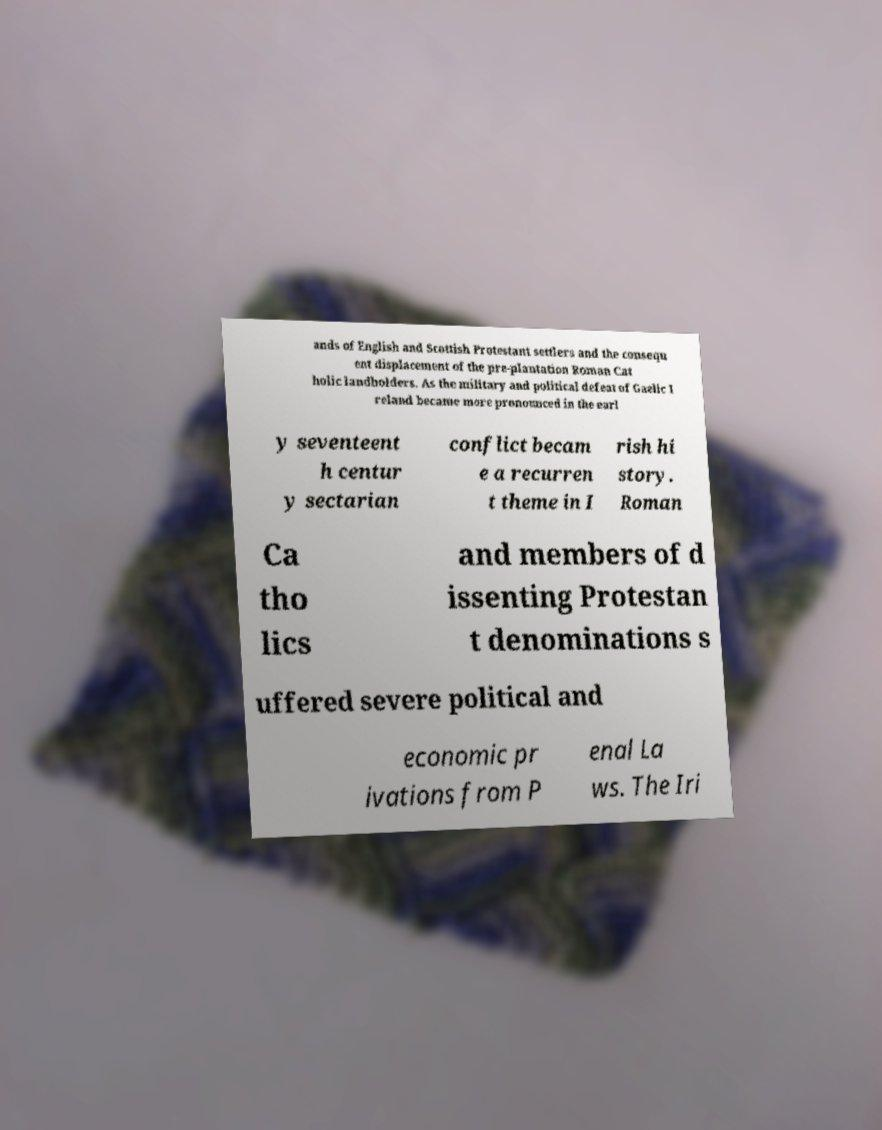There's text embedded in this image that I need extracted. Can you transcribe it verbatim? ands of English and Scottish Protestant settlers and the consequ ent displacement of the pre-plantation Roman Cat holic landholders. As the military and political defeat of Gaelic I reland became more pronounced in the earl y seventeent h centur y sectarian conflict becam e a recurren t theme in I rish hi story. Roman Ca tho lics and members of d issenting Protestan t denominations s uffered severe political and economic pr ivations from P enal La ws. The Iri 